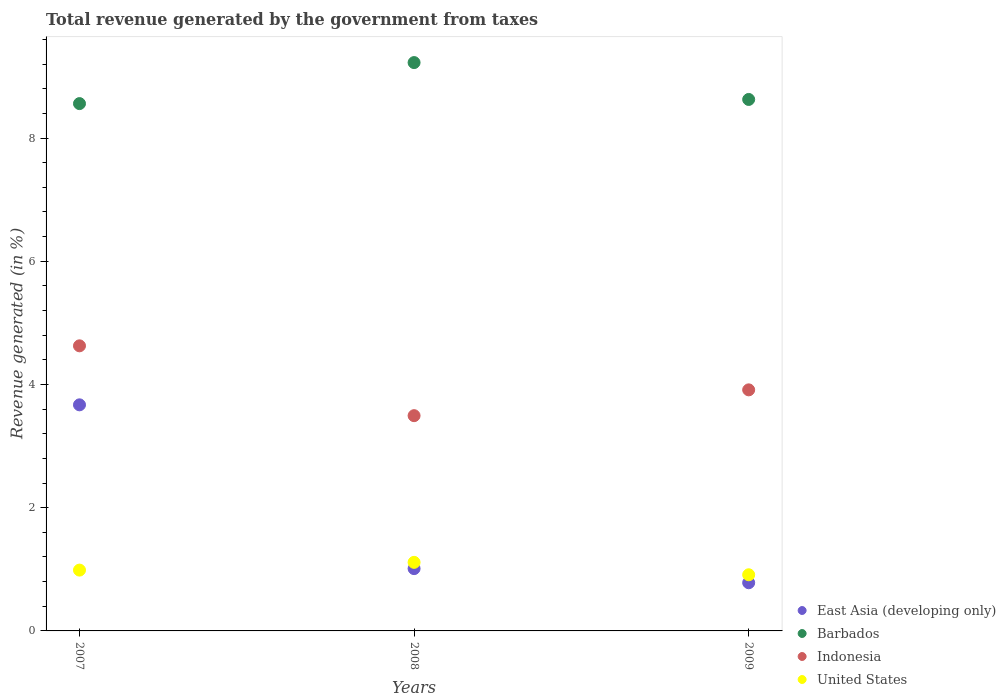How many different coloured dotlines are there?
Your answer should be very brief. 4. Is the number of dotlines equal to the number of legend labels?
Give a very brief answer. Yes. What is the total revenue generated in Barbados in 2009?
Ensure brevity in your answer.  8.63. Across all years, what is the maximum total revenue generated in Barbados?
Your answer should be very brief. 9.23. Across all years, what is the minimum total revenue generated in Barbados?
Provide a short and direct response. 8.56. In which year was the total revenue generated in United States minimum?
Your response must be concise. 2009. What is the total total revenue generated in East Asia (developing only) in the graph?
Give a very brief answer. 5.46. What is the difference between the total revenue generated in East Asia (developing only) in 2007 and that in 2008?
Your answer should be very brief. 2.66. What is the difference between the total revenue generated in Indonesia in 2008 and the total revenue generated in United States in 2007?
Give a very brief answer. 2.51. What is the average total revenue generated in Barbados per year?
Provide a succinct answer. 8.8. In the year 2008, what is the difference between the total revenue generated in East Asia (developing only) and total revenue generated in Indonesia?
Provide a short and direct response. -2.48. What is the ratio of the total revenue generated in Indonesia in 2007 to that in 2009?
Make the answer very short. 1.18. Is the total revenue generated in East Asia (developing only) in 2007 less than that in 2009?
Give a very brief answer. No. Is the difference between the total revenue generated in East Asia (developing only) in 2007 and 2008 greater than the difference between the total revenue generated in Indonesia in 2007 and 2008?
Provide a short and direct response. Yes. What is the difference between the highest and the second highest total revenue generated in Indonesia?
Your response must be concise. 0.71. What is the difference between the highest and the lowest total revenue generated in East Asia (developing only)?
Offer a terse response. 2.89. Is it the case that in every year, the sum of the total revenue generated in United States and total revenue generated in East Asia (developing only)  is greater than the sum of total revenue generated in Barbados and total revenue generated in Indonesia?
Provide a succinct answer. No. Does the total revenue generated in Indonesia monotonically increase over the years?
Keep it short and to the point. No. Is the total revenue generated in East Asia (developing only) strictly greater than the total revenue generated in Barbados over the years?
Give a very brief answer. No. Is the total revenue generated in Indonesia strictly less than the total revenue generated in Barbados over the years?
Offer a terse response. Yes. How many dotlines are there?
Your answer should be very brief. 4. How many years are there in the graph?
Give a very brief answer. 3. Does the graph contain any zero values?
Provide a short and direct response. No. Where does the legend appear in the graph?
Provide a succinct answer. Bottom right. How many legend labels are there?
Your answer should be compact. 4. What is the title of the graph?
Give a very brief answer. Total revenue generated by the government from taxes. Does "Kazakhstan" appear as one of the legend labels in the graph?
Keep it short and to the point. No. What is the label or title of the X-axis?
Give a very brief answer. Years. What is the label or title of the Y-axis?
Provide a succinct answer. Revenue generated (in %). What is the Revenue generated (in %) of East Asia (developing only) in 2007?
Make the answer very short. 3.67. What is the Revenue generated (in %) in Barbados in 2007?
Provide a succinct answer. 8.56. What is the Revenue generated (in %) in Indonesia in 2007?
Your answer should be compact. 4.63. What is the Revenue generated (in %) of United States in 2007?
Your response must be concise. 0.99. What is the Revenue generated (in %) in East Asia (developing only) in 2008?
Keep it short and to the point. 1.01. What is the Revenue generated (in %) in Barbados in 2008?
Make the answer very short. 9.23. What is the Revenue generated (in %) of Indonesia in 2008?
Offer a very short reply. 3.49. What is the Revenue generated (in %) in United States in 2008?
Provide a short and direct response. 1.11. What is the Revenue generated (in %) of East Asia (developing only) in 2009?
Provide a short and direct response. 0.78. What is the Revenue generated (in %) of Barbados in 2009?
Make the answer very short. 8.63. What is the Revenue generated (in %) of Indonesia in 2009?
Your answer should be compact. 3.91. What is the Revenue generated (in %) of United States in 2009?
Give a very brief answer. 0.91. Across all years, what is the maximum Revenue generated (in %) in East Asia (developing only)?
Provide a short and direct response. 3.67. Across all years, what is the maximum Revenue generated (in %) in Barbados?
Your answer should be compact. 9.23. Across all years, what is the maximum Revenue generated (in %) in Indonesia?
Ensure brevity in your answer.  4.63. Across all years, what is the maximum Revenue generated (in %) in United States?
Provide a short and direct response. 1.11. Across all years, what is the minimum Revenue generated (in %) of East Asia (developing only)?
Give a very brief answer. 0.78. Across all years, what is the minimum Revenue generated (in %) in Barbados?
Give a very brief answer. 8.56. Across all years, what is the minimum Revenue generated (in %) of Indonesia?
Give a very brief answer. 3.49. Across all years, what is the minimum Revenue generated (in %) of United States?
Your answer should be compact. 0.91. What is the total Revenue generated (in %) in East Asia (developing only) in the graph?
Give a very brief answer. 5.46. What is the total Revenue generated (in %) in Barbados in the graph?
Offer a very short reply. 26.41. What is the total Revenue generated (in %) of Indonesia in the graph?
Your answer should be compact. 12.03. What is the total Revenue generated (in %) of United States in the graph?
Keep it short and to the point. 3.01. What is the difference between the Revenue generated (in %) of East Asia (developing only) in 2007 and that in 2008?
Keep it short and to the point. 2.66. What is the difference between the Revenue generated (in %) of Barbados in 2007 and that in 2008?
Your answer should be compact. -0.67. What is the difference between the Revenue generated (in %) of Indonesia in 2007 and that in 2008?
Provide a succinct answer. 1.13. What is the difference between the Revenue generated (in %) in United States in 2007 and that in 2008?
Ensure brevity in your answer.  -0.13. What is the difference between the Revenue generated (in %) in East Asia (developing only) in 2007 and that in 2009?
Ensure brevity in your answer.  2.89. What is the difference between the Revenue generated (in %) in Barbados in 2007 and that in 2009?
Your answer should be compact. -0.07. What is the difference between the Revenue generated (in %) in Indonesia in 2007 and that in 2009?
Make the answer very short. 0.71. What is the difference between the Revenue generated (in %) in United States in 2007 and that in 2009?
Give a very brief answer. 0.08. What is the difference between the Revenue generated (in %) of East Asia (developing only) in 2008 and that in 2009?
Offer a very short reply. 0.23. What is the difference between the Revenue generated (in %) of Barbados in 2008 and that in 2009?
Your answer should be very brief. 0.6. What is the difference between the Revenue generated (in %) in Indonesia in 2008 and that in 2009?
Make the answer very short. -0.42. What is the difference between the Revenue generated (in %) in United States in 2008 and that in 2009?
Give a very brief answer. 0.2. What is the difference between the Revenue generated (in %) of East Asia (developing only) in 2007 and the Revenue generated (in %) of Barbados in 2008?
Your response must be concise. -5.56. What is the difference between the Revenue generated (in %) in East Asia (developing only) in 2007 and the Revenue generated (in %) in Indonesia in 2008?
Make the answer very short. 0.18. What is the difference between the Revenue generated (in %) of East Asia (developing only) in 2007 and the Revenue generated (in %) of United States in 2008?
Offer a terse response. 2.56. What is the difference between the Revenue generated (in %) of Barbados in 2007 and the Revenue generated (in %) of Indonesia in 2008?
Offer a terse response. 5.07. What is the difference between the Revenue generated (in %) in Barbados in 2007 and the Revenue generated (in %) in United States in 2008?
Make the answer very short. 7.45. What is the difference between the Revenue generated (in %) in Indonesia in 2007 and the Revenue generated (in %) in United States in 2008?
Your answer should be very brief. 3.51. What is the difference between the Revenue generated (in %) of East Asia (developing only) in 2007 and the Revenue generated (in %) of Barbados in 2009?
Offer a terse response. -4.96. What is the difference between the Revenue generated (in %) in East Asia (developing only) in 2007 and the Revenue generated (in %) in Indonesia in 2009?
Your answer should be very brief. -0.24. What is the difference between the Revenue generated (in %) of East Asia (developing only) in 2007 and the Revenue generated (in %) of United States in 2009?
Provide a short and direct response. 2.76. What is the difference between the Revenue generated (in %) in Barbados in 2007 and the Revenue generated (in %) in Indonesia in 2009?
Provide a succinct answer. 4.65. What is the difference between the Revenue generated (in %) in Barbados in 2007 and the Revenue generated (in %) in United States in 2009?
Provide a succinct answer. 7.65. What is the difference between the Revenue generated (in %) of Indonesia in 2007 and the Revenue generated (in %) of United States in 2009?
Keep it short and to the point. 3.72. What is the difference between the Revenue generated (in %) in East Asia (developing only) in 2008 and the Revenue generated (in %) in Barbados in 2009?
Your response must be concise. -7.62. What is the difference between the Revenue generated (in %) of East Asia (developing only) in 2008 and the Revenue generated (in %) of Indonesia in 2009?
Keep it short and to the point. -2.9. What is the difference between the Revenue generated (in %) in East Asia (developing only) in 2008 and the Revenue generated (in %) in United States in 2009?
Give a very brief answer. 0.1. What is the difference between the Revenue generated (in %) in Barbados in 2008 and the Revenue generated (in %) in Indonesia in 2009?
Provide a short and direct response. 5.31. What is the difference between the Revenue generated (in %) in Barbados in 2008 and the Revenue generated (in %) in United States in 2009?
Provide a short and direct response. 8.31. What is the difference between the Revenue generated (in %) in Indonesia in 2008 and the Revenue generated (in %) in United States in 2009?
Provide a short and direct response. 2.58. What is the average Revenue generated (in %) in East Asia (developing only) per year?
Make the answer very short. 1.82. What is the average Revenue generated (in %) of Barbados per year?
Provide a short and direct response. 8.8. What is the average Revenue generated (in %) in Indonesia per year?
Provide a succinct answer. 4.01. In the year 2007, what is the difference between the Revenue generated (in %) of East Asia (developing only) and Revenue generated (in %) of Barbados?
Give a very brief answer. -4.89. In the year 2007, what is the difference between the Revenue generated (in %) in East Asia (developing only) and Revenue generated (in %) in Indonesia?
Provide a short and direct response. -0.96. In the year 2007, what is the difference between the Revenue generated (in %) of East Asia (developing only) and Revenue generated (in %) of United States?
Provide a short and direct response. 2.68. In the year 2007, what is the difference between the Revenue generated (in %) in Barbados and Revenue generated (in %) in Indonesia?
Make the answer very short. 3.93. In the year 2007, what is the difference between the Revenue generated (in %) in Barbados and Revenue generated (in %) in United States?
Your answer should be very brief. 7.57. In the year 2007, what is the difference between the Revenue generated (in %) in Indonesia and Revenue generated (in %) in United States?
Provide a short and direct response. 3.64. In the year 2008, what is the difference between the Revenue generated (in %) in East Asia (developing only) and Revenue generated (in %) in Barbados?
Provide a short and direct response. -8.21. In the year 2008, what is the difference between the Revenue generated (in %) in East Asia (developing only) and Revenue generated (in %) in Indonesia?
Keep it short and to the point. -2.48. In the year 2008, what is the difference between the Revenue generated (in %) in East Asia (developing only) and Revenue generated (in %) in United States?
Give a very brief answer. -0.1. In the year 2008, what is the difference between the Revenue generated (in %) in Barbados and Revenue generated (in %) in Indonesia?
Give a very brief answer. 5.73. In the year 2008, what is the difference between the Revenue generated (in %) of Barbados and Revenue generated (in %) of United States?
Make the answer very short. 8.11. In the year 2008, what is the difference between the Revenue generated (in %) in Indonesia and Revenue generated (in %) in United States?
Keep it short and to the point. 2.38. In the year 2009, what is the difference between the Revenue generated (in %) of East Asia (developing only) and Revenue generated (in %) of Barbados?
Keep it short and to the point. -7.84. In the year 2009, what is the difference between the Revenue generated (in %) in East Asia (developing only) and Revenue generated (in %) in Indonesia?
Keep it short and to the point. -3.13. In the year 2009, what is the difference between the Revenue generated (in %) in East Asia (developing only) and Revenue generated (in %) in United States?
Provide a short and direct response. -0.13. In the year 2009, what is the difference between the Revenue generated (in %) in Barbados and Revenue generated (in %) in Indonesia?
Make the answer very short. 4.71. In the year 2009, what is the difference between the Revenue generated (in %) in Barbados and Revenue generated (in %) in United States?
Keep it short and to the point. 7.72. In the year 2009, what is the difference between the Revenue generated (in %) of Indonesia and Revenue generated (in %) of United States?
Provide a succinct answer. 3. What is the ratio of the Revenue generated (in %) in East Asia (developing only) in 2007 to that in 2008?
Offer a very short reply. 3.63. What is the ratio of the Revenue generated (in %) of Barbados in 2007 to that in 2008?
Offer a very short reply. 0.93. What is the ratio of the Revenue generated (in %) of Indonesia in 2007 to that in 2008?
Give a very brief answer. 1.32. What is the ratio of the Revenue generated (in %) in United States in 2007 to that in 2008?
Ensure brevity in your answer.  0.89. What is the ratio of the Revenue generated (in %) of East Asia (developing only) in 2007 to that in 2009?
Your answer should be very brief. 4.69. What is the ratio of the Revenue generated (in %) in Barbados in 2007 to that in 2009?
Provide a succinct answer. 0.99. What is the ratio of the Revenue generated (in %) in Indonesia in 2007 to that in 2009?
Offer a very short reply. 1.18. What is the ratio of the Revenue generated (in %) in United States in 2007 to that in 2009?
Offer a very short reply. 1.08. What is the ratio of the Revenue generated (in %) of East Asia (developing only) in 2008 to that in 2009?
Provide a short and direct response. 1.29. What is the ratio of the Revenue generated (in %) in Barbados in 2008 to that in 2009?
Your answer should be very brief. 1.07. What is the ratio of the Revenue generated (in %) of Indonesia in 2008 to that in 2009?
Offer a very short reply. 0.89. What is the ratio of the Revenue generated (in %) of United States in 2008 to that in 2009?
Your answer should be compact. 1.22. What is the difference between the highest and the second highest Revenue generated (in %) in East Asia (developing only)?
Make the answer very short. 2.66. What is the difference between the highest and the second highest Revenue generated (in %) of Barbados?
Offer a very short reply. 0.6. What is the difference between the highest and the second highest Revenue generated (in %) of Indonesia?
Provide a short and direct response. 0.71. What is the difference between the highest and the second highest Revenue generated (in %) in United States?
Give a very brief answer. 0.13. What is the difference between the highest and the lowest Revenue generated (in %) of East Asia (developing only)?
Provide a short and direct response. 2.89. What is the difference between the highest and the lowest Revenue generated (in %) of Barbados?
Provide a succinct answer. 0.67. What is the difference between the highest and the lowest Revenue generated (in %) of Indonesia?
Your answer should be compact. 1.13. What is the difference between the highest and the lowest Revenue generated (in %) in United States?
Provide a short and direct response. 0.2. 